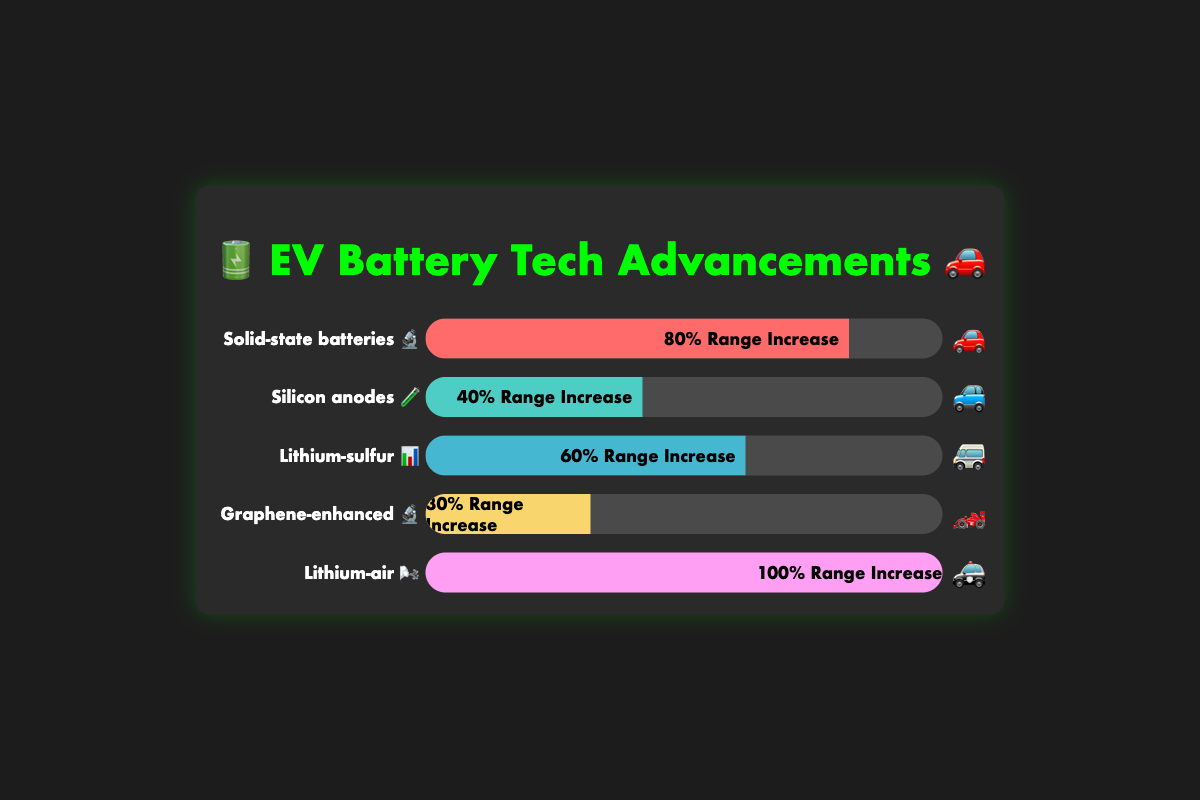what is the range increase for Solid-state batteries? From the figure, the range increase for Solid-state batteries is shown in a bar labeled "Solid-state batteries 🔬" with an "80% Range Increase" text inside the bar.
Answer: 80% Which battery technology offers the highest range increase? By examining the figure, the bar labeled "Lithium-air 🌬️" shows a "100% Range Increase," which is the highest among all the battery technologies listed.
Answer: Lithium-air How much less is the range increase for Silicon anodes compared to Lithium-sulfur? Silicon anodes have a "40% Range Increase", and Lithium-sulfur has a "60% Range Increase". The difference is 60% - 40% = 20%.
Answer: 20% How many types of battery technologies are displayed in the figure? The figure shows five different battery technologies, each labeled with their respective names and emojis.
Answer: 5 Which two battery technologies have the closest range increases, and what are their values? Graphene-enhanced has a "30% Range Increase" and Silicon anodes have a "40% Range Increase". They differ by only 10%.
Answer: Graphene-enhanced (30%) and Silicon anodes (40%) What is the average range increase across all battery technologies shown? The range increases are 80%, 40%, 60%, 30%, and 100%. Sum these values: 80 + 40 + 60 + 30 + 100 = 310. Divide by 5 (the number of technologies): 310 / 5 = 62%.
Answer: 62% Which battery technology is associated with the emoji 🚓? From the figure, the bar labeled "Lithium-air 🌬️" ends with the emoji 🚓.
Answer: Lithium-air 